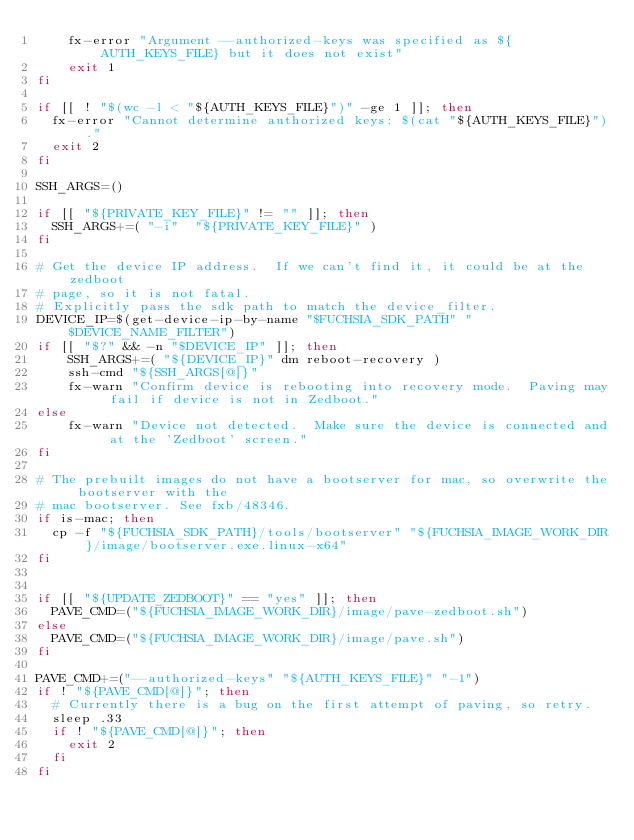<code> <loc_0><loc_0><loc_500><loc_500><_Bash_>    fx-error "Argument --authorized-keys was specified as ${AUTH_KEYS_FILE} but it does not exist"
    exit 1
fi

if [[ ! "$(wc -l < "${AUTH_KEYS_FILE}")" -ge 1 ]]; then
  fx-error "Cannot determine authorized keys: $(cat "${AUTH_KEYS_FILE}")."
  exit 2
fi

SSH_ARGS=()

if [[ "${PRIVATE_KEY_FILE}" != "" ]]; then
  SSH_ARGS+=( "-i"  "${PRIVATE_KEY_FILE}" )
fi

# Get the device IP address.  If we can't find it, it could be at the zedboot
# page, so it is not fatal.
# Explicitly pass the sdk path to match the device_filter.
DEVICE_IP=$(get-device-ip-by-name "$FUCHSIA_SDK_PATH" "$DEVICE_NAME_FILTER")
if [[ "$?" && -n "$DEVICE_IP" ]]; then
    SSH_ARGS+=( "${DEVICE_IP}" dm reboot-recovery )
    ssh-cmd "${SSH_ARGS[@]}"
    fx-warn "Confirm device is rebooting into recovery mode.  Paving may fail if device is not in Zedboot."
else
    fx-warn "Device not detected.  Make sure the device is connected and at the 'Zedboot' screen."
fi

# The prebuilt images do not have a bootserver for mac, so overwrite the bootserver with the
# mac bootserver. See fxb/48346.
if is-mac; then
  cp -f "${FUCHSIA_SDK_PATH}/tools/bootserver" "${FUCHSIA_IMAGE_WORK_DIR}/image/bootserver.exe.linux-x64"
fi


if [[ "${UPDATE_ZEDBOOT}" == "yes" ]]; then
  PAVE_CMD=("${FUCHSIA_IMAGE_WORK_DIR}/image/pave-zedboot.sh")
else
  PAVE_CMD=("${FUCHSIA_IMAGE_WORK_DIR}/image/pave.sh")
fi

PAVE_CMD+=("--authorized-keys" "${AUTH_KEYS_FILE}" "-1")
if ! "${PAVE_CMD[@]}"; then
  # Currently there is a bug on the first attempt of paving, so retry.
  sleep .33
  if ! "${PAVE_CMD[@]}"; then
    exit 2
  fi
fi
</code> 